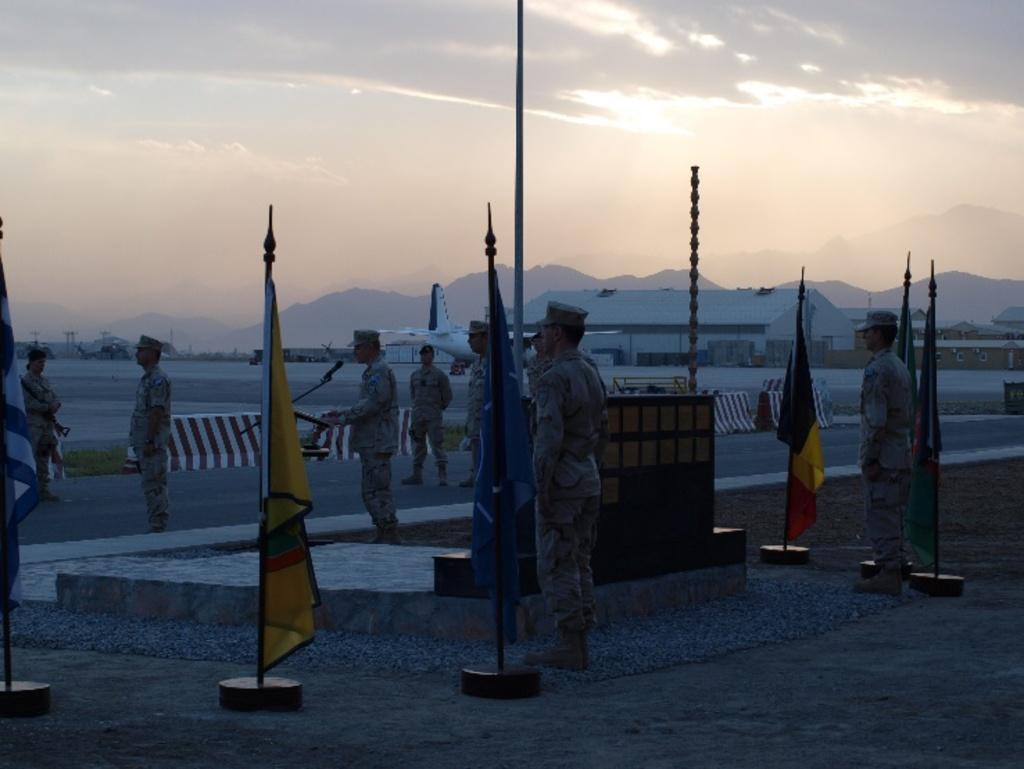How many people are in the image? There are persons in the image, but the exact number is not specified. What is on the ground near the persons? There are flags on the ground. What can be seen in the background of the image? There is an aeroplane, at least one building, hills, and sky visible in the background of the image. What is the condition of the sky in the image? The sky is visible in the background of the image, and there are clouds present. What type of lumber is being used to help the aeroplane take off in the image? There is no lumber or indication of an aeroplane taking off in the image. Can you see any smoke coming from the building in the image? There is no smoke visible in the image; only the aeroplane, building, hills, and sky are present. 